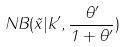Convert formula to latex. <formula><loc_0><loc_0><loc_500><loc_500>N B ( \tilde { x } | k ^ { \prime } , \frac { \theta ^ { \prime } } { 1 + \theta ^ { \prime } } )</formula> 